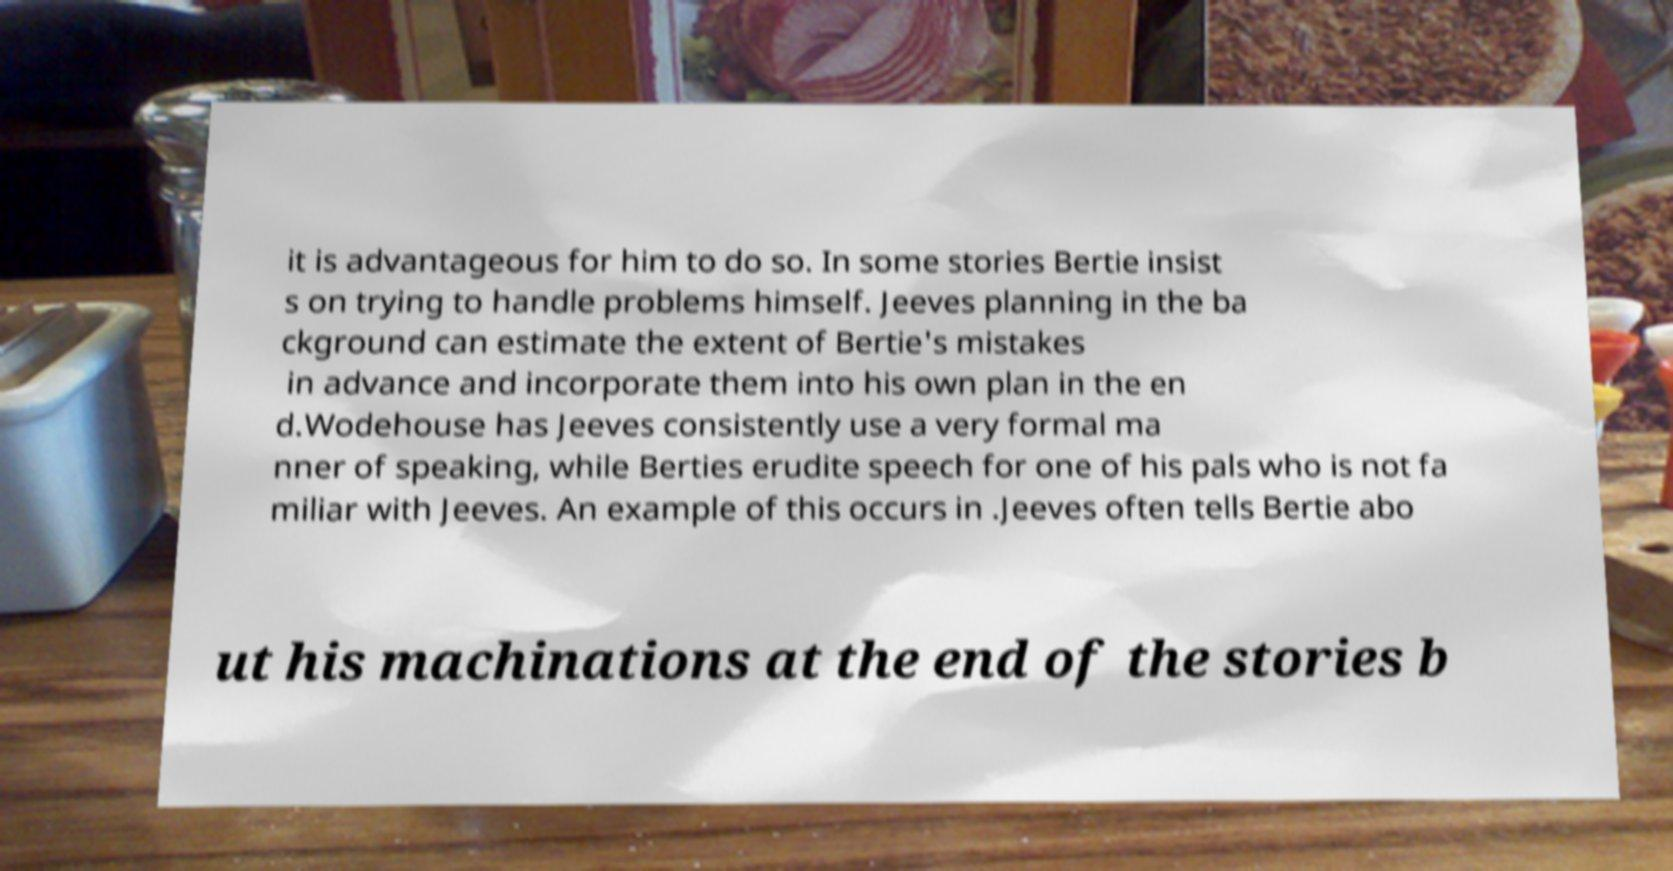Could you extract and type out the text from this image? it is advantageous for him to do so. In some stories Bertie insist s on trying to handle problems himself. Jeeves planning in the ba ckground can estimate the extent of Bertie's mistakes in advance and incorporate them into his own plan in the en d.Wodehouse has Jeeves consistently use a very formal ma nner of speaking, while Berties erudite speech for one of his pals who is not fa miliar with Jeeves. An example of this occurs in .Jeeves often tells Bertie abo ut his machinations at the end of the stories b 